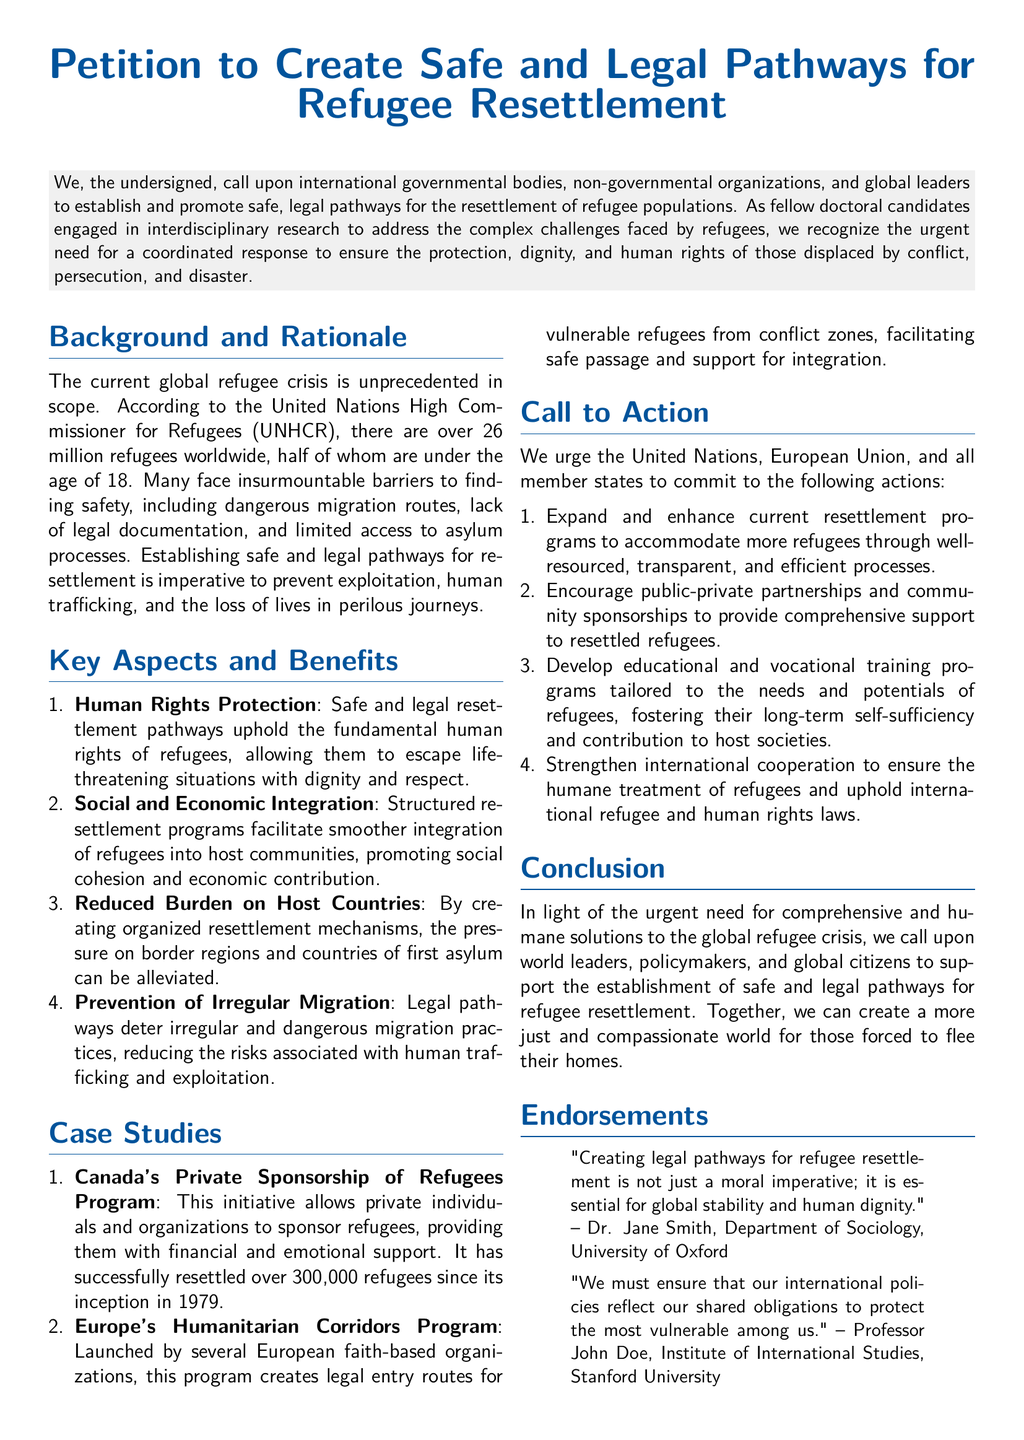What is the main purpose of the petition? The main purpose of the petition is to call for establishing and promoting safe, legal pathways for the resettlement of refugee populations.
Answer: safe and legal pathways for refugee resettlement How many refugees are there worldwide according to UNHCR? The document states that there are over 26 million refugees worldwide according to UNHCR.
Answer: over 26 million What is one benefit of safe resettlement pathways mentioned? The document lists "Human Rights Protection" as a benefit of safe and legal resettlement pathways.
Answer: Human Rights Protection How many refugees has Canada successfully resettled through its program since 1979? The document provides the information that Canada has successfully resettled over 300,000 refugees since 1979.
Answer: over 300,000 What action does the petition urge regarding educational programs? The petition calls for the development of educational and vocational training programs tailored to the needs and potentials of refugees.
Answer: educational and vocational training programs Who is quoted in the endorsements section? The document features Dr. Jane Smith and Professor John Doe in the endorsements section.
Answer: Dr. Jane Smith, Professor John Doe What overall issue does the document address? The document addresses the global refugee crisis as an unprecedented issue.
Answer: global refugee crisis Which program is associated with vulnerable refugees in Europe? The document refers to the "Humanitarian Corridors Program" for vulnerable refugees in Europe.
Answer: Humanitarian Corridors Program 